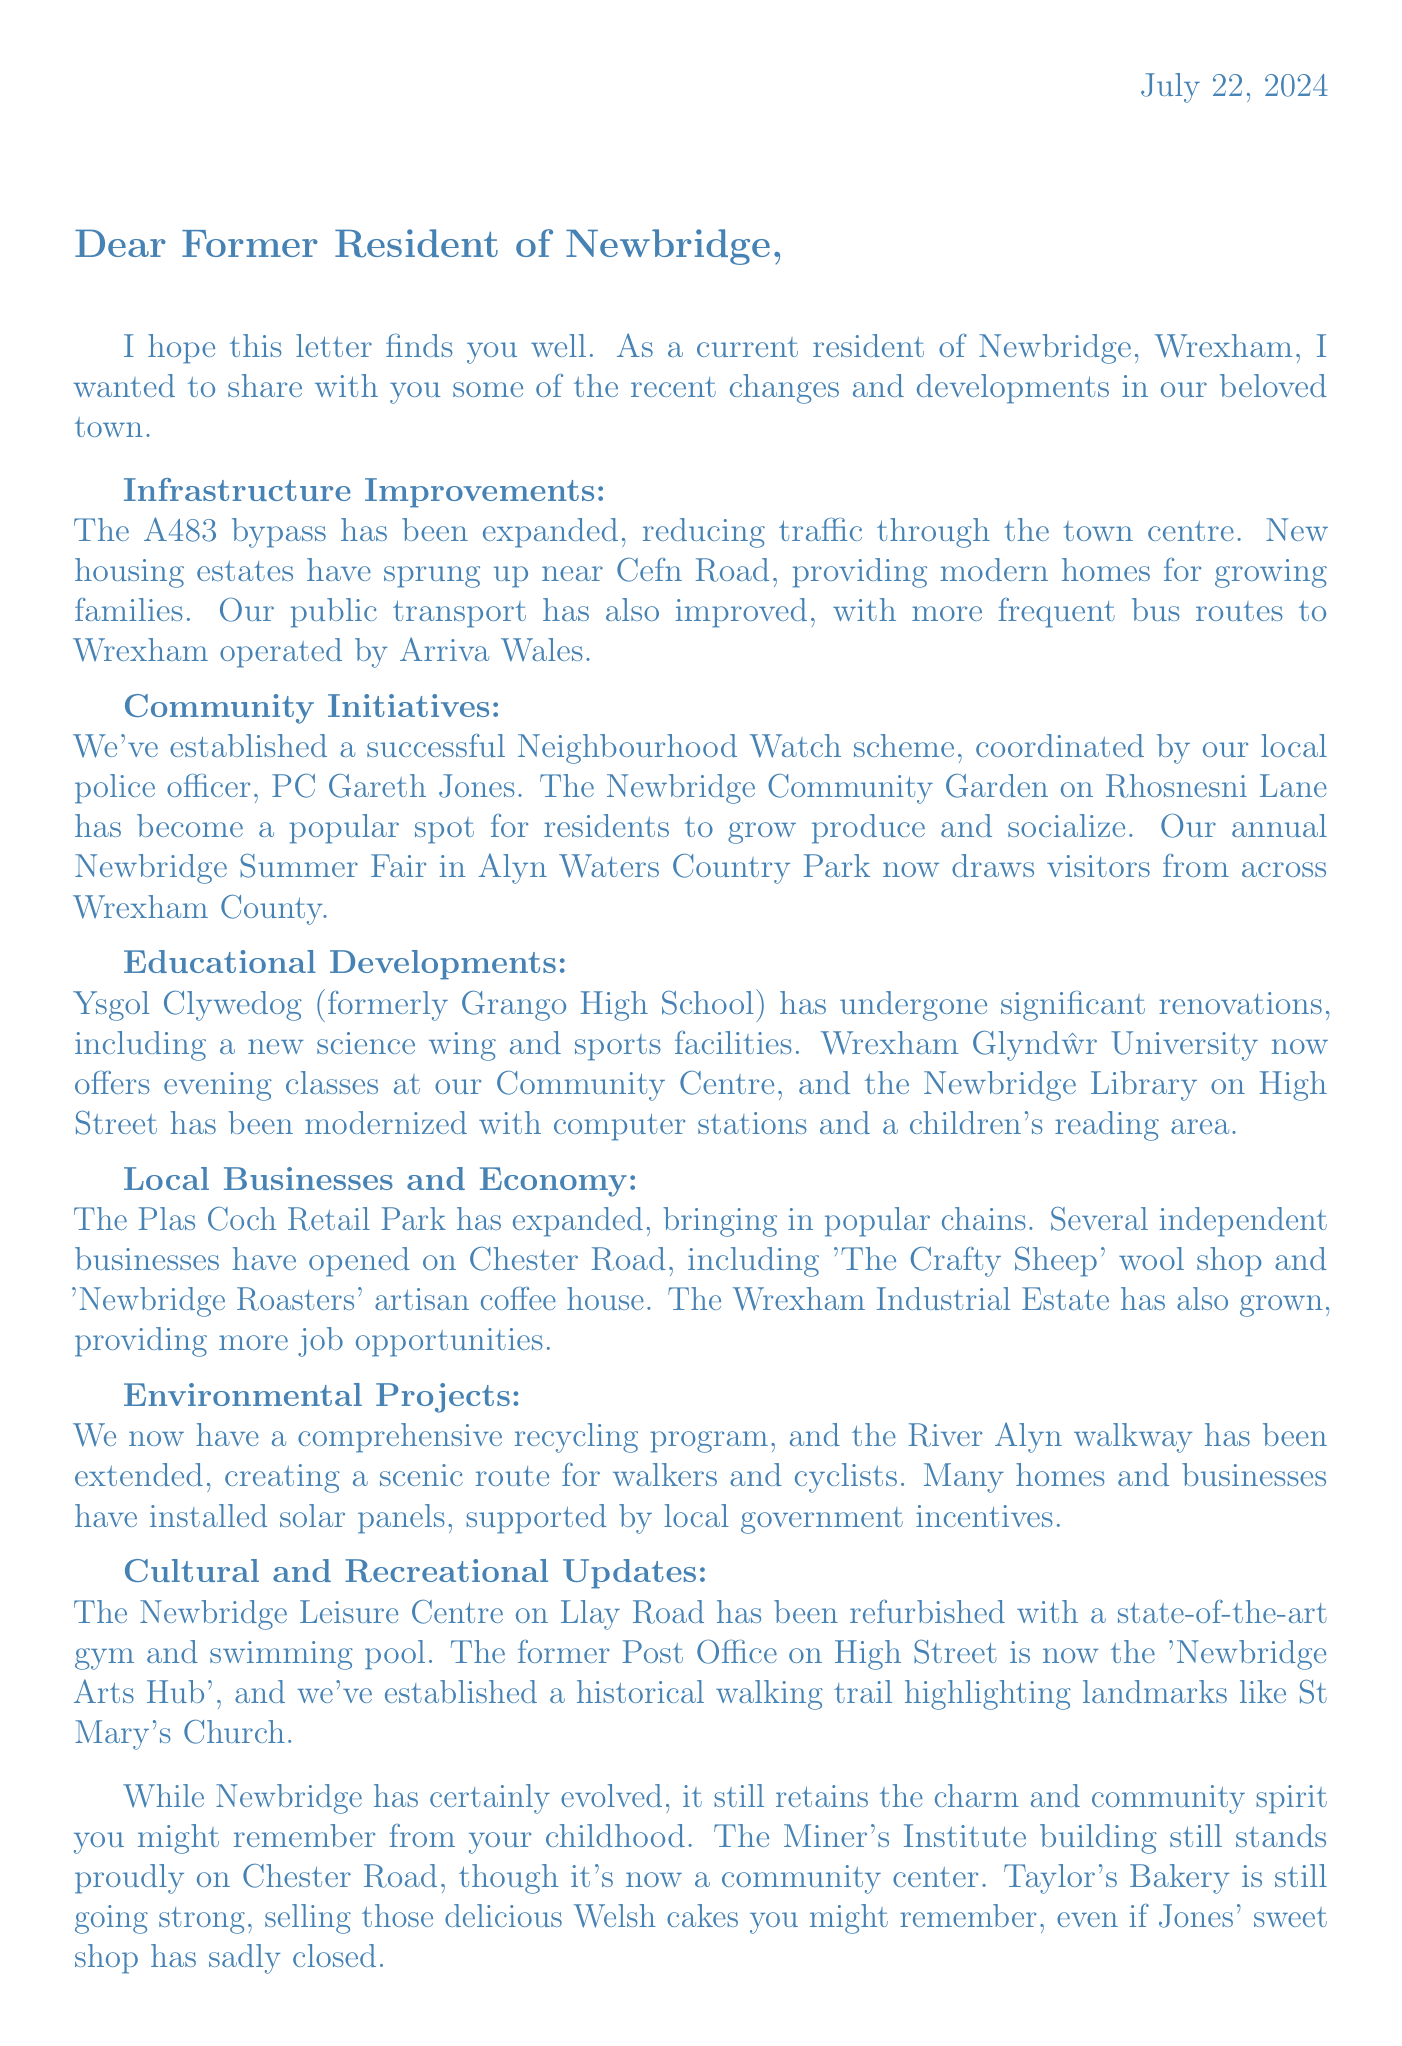What recent infrastructure development has been made to reduce traffic? The letter mentions that the A483 bypass has been expanded to reduce traffic through the town centre.
Answer: A483 bypass expansion What community initiative has been established in Newbridge? The letter states that a Neighbourhood Watch scheme has been established, coordinated by PC Gareth Jones.
Answer: Neighbourhood Watch scheme What major annual event is held in Newbridge? The letter describes the Newbridge Summer Fair as a major event drawing visitors from across Wrexham County.
Answer: Newbridge Summer Fair Which educational institution has undergone significant renovations? The letter states that Ysgol Clywedog has undergone significant renovations, including a new science wing.
Answer: Ysgol Clywedog What type of new facilities have been added to the Newbridge Leisure Centre? The letter mentions that the Newbridge Leisure Centre has been refurbished and now features a state-of-the-art gym and swimming pool.
Answer: State-of-the-art gym and swimming pool What has replaced the former Post Office building on High Street? According to the letter, the former Post Office has been converted into the 'Newbridge Arts Hub.'
Answer: Newbridge Arts Hub What historical site is still standing on Chester Road? The letter indicates that the Miner's Institute building still stands proudly as a community center.
Answer: Miner's Institute building How has public transport improved recently? The letter states that the bus service to Wrexham has been improved with more frequent routes operated by Arriva Wales.
Answer: More frequent bus routes What environmental project has been introduced in Newbridge? The letter mentions that Wrexham County Borough Council has introduced a comprehensive recycling program.
Answer: Comprehensive recycling program 